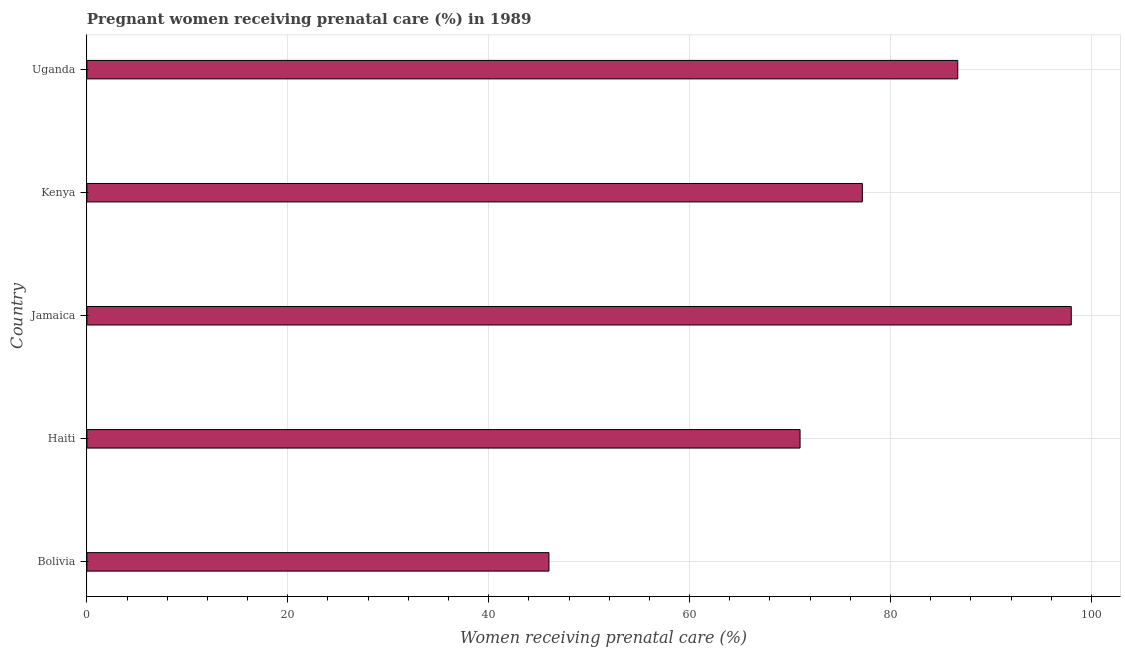Does the graph contain grids?
Offer a very short reply. Yes. What is the title of the graph?
Offer a very short reply. Pregnant women receiving prenatal care (%) in 1989. What is the label or title of the X-axis?
Your response must be concise. Women receiving prenatal care (%). What is the percentage of pregnant women receiving prenatal care in Bolivia?
Provide a succinct answer. 46. Across all countries, what is the maximum percentage of pregnant women receiving prenatal care?
Your answer should be compact. 98. In which country was the percentage of pregnant women receiving prenatal care maximum?
Make the answer very short. Jamaica. In which country was the percentage of pregnant women receiving prenatal care minimum?
Give a very brief answer. Bolivia. What is the sum of the percentage of pregnant women receiving prenatal care?
Offer a terse response. 378.9. What is the difference between the percentage of pregnant women receiving prenatal care in Haiti and Uganda?
Provide a short and direct response. -15.7. What is the average percentage of pregnant women receiving prenatal care per country?
Your answer should be very brief. 75.78. What is the median percentage of pregnant women receiving prenatal care?
Your answer should be compact. 77.2. In how many countries, is the percentage of pregnant women receiving prenatal care greater than 20 %?
Your answer should be compact. 5. What is the ratio of the percentage of pregnant women receiving prenatal care in Bolivia to that in Uganda?
Your response must be concise. 0.53. Is the percentage of pregnant women receiving prenatal care in Jamaica less than that in Kenya?
Give a very brief answer. No. What is the difference between the highest and the second highest percentage of pregnant women receiving prenatal care?
Offer a terse response. 11.3. Is the sum of the percentage of pregnant women receiving prenatal care in Jamaica and Uganda greater than the maximum percentage of pregnant women receiving prenatal care across all countries?
Offer a very short reply. Yes. How many bars are there?
Provide a short and direct response. 5. What is the difference between two consecutive major ticks on the X-axis?
Offer a terse response. 20. Are the values on the major ticks of X-axis written in scientific E-notation?
Give a very brief answer. No. What is the Women receiving prenatal care (%) in Haiti?
Your response must be concise. 71. What is the Women receiving prenatal care (%) in Jamaica?
Ensure brevity in your answer.  98. What is the Women receiving prenatal care (%) in Kenya?
Ensure brevity in your answer.  77.2. What is the Women receiving prenatal care (%) in Uganda?
Provide a short and direct response. 86.7. What is the difference between the Women receiving prenatal care (%) in Bolivia and Haiti?
Offer a terse response. -25. What is the difference between the Women receiving prenatal care (%) in Bolivia and Jamaica?
Give a very brief answer. -52. What is the difference between the Women receiving prenatal care (%) in Bolivia and Kenya?
Offer a very short reply. -31.2. What is the difference between the Women receiving prenatal care (%) in Bolivia and Uganda?
Your answer should be very brief. -40.7. What is the difference between the Women receiving prenatal care (%) in Haiti and Jamaica?
Provide a succinct answer. -27. What is the difference between the Women receiving prenatal care (%) in Haiti and Kenya?
Provide a succinct answer. -6.2. What is the difference between the Women receiving prenatal care (%) in Haiti and Uganda?
Provide a succinct answer. -15.7. What is the difference between the Women receiving prenatal care (%) in Jamaica and Kenya?
Make the answer very short. 20.8. What is the difference between the Women receiving prenatal care (%) in Kenya and Uganda?
Keep it short and to the point. -9.5. What is the ratio of the Women receiving prenatal care (%) in Bolivia to that in Haiti?
Give a very brief answer. 0.65. What is the ratio of the Women receiving prenatal care (%) in Bolivia to that in Jamaica?
Give a very brief answer. 0.47. What is the ratio of the Women receiving prenatal care (%) in Bolivia to that in Kenya?
Offer a terse response. 0.6. What is the ratio of the Women receiving prenatal care (%) in Bolivia to that in Uganda?
Give a very brief answer. 0.53. What is the ratio of the Women receiving prenatal care (%) in Haiti to that in Jamaica?
Keep it short and to the point. 0.72. What is the ratio of the Women receiving prenatal care (%) in Haiti to that in Kenya?
Your response must be concise. 0.92. What is the ratio of the Women receiving prenatal care (%) in Haiti to that in Uganda?
Keep it short and to the point. 0.82. What is the ratio of the Women receiving prenatal care (%) in Jamaica to that in Kenya?
Ensure brevity in your answer.  1.27. What is the ratio of the Women receiving prenatal care (%) in Jamaica to that in Uganda?
Offer a terse response. 1.13. What is the ratio of the Women receiving prenatal care (%) in Kenya to that in Uganda?
Your answer should be compact. 0.89. 